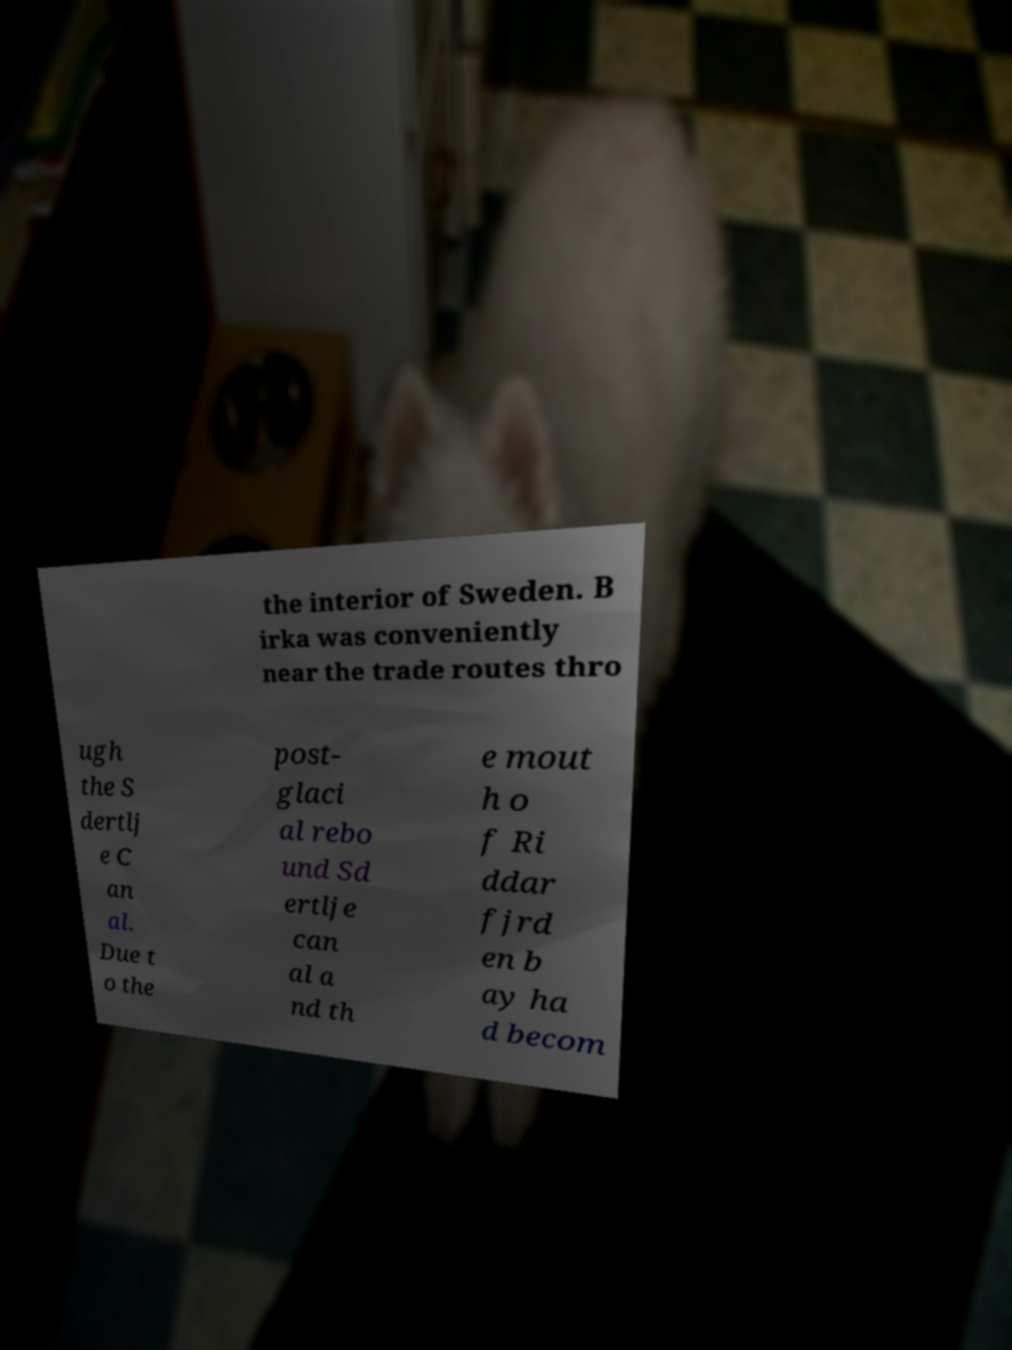Please read and relay the text visible in this image. What does it say? the interior of Sweden. B irka was conveniently near the trade routes thro ugh the S dertlj e C an al. Due t o the post- glaci al rebo und Sd ertlje can al a nd th e mout h o f Ri ddar fjrd en b ay ha d becom 